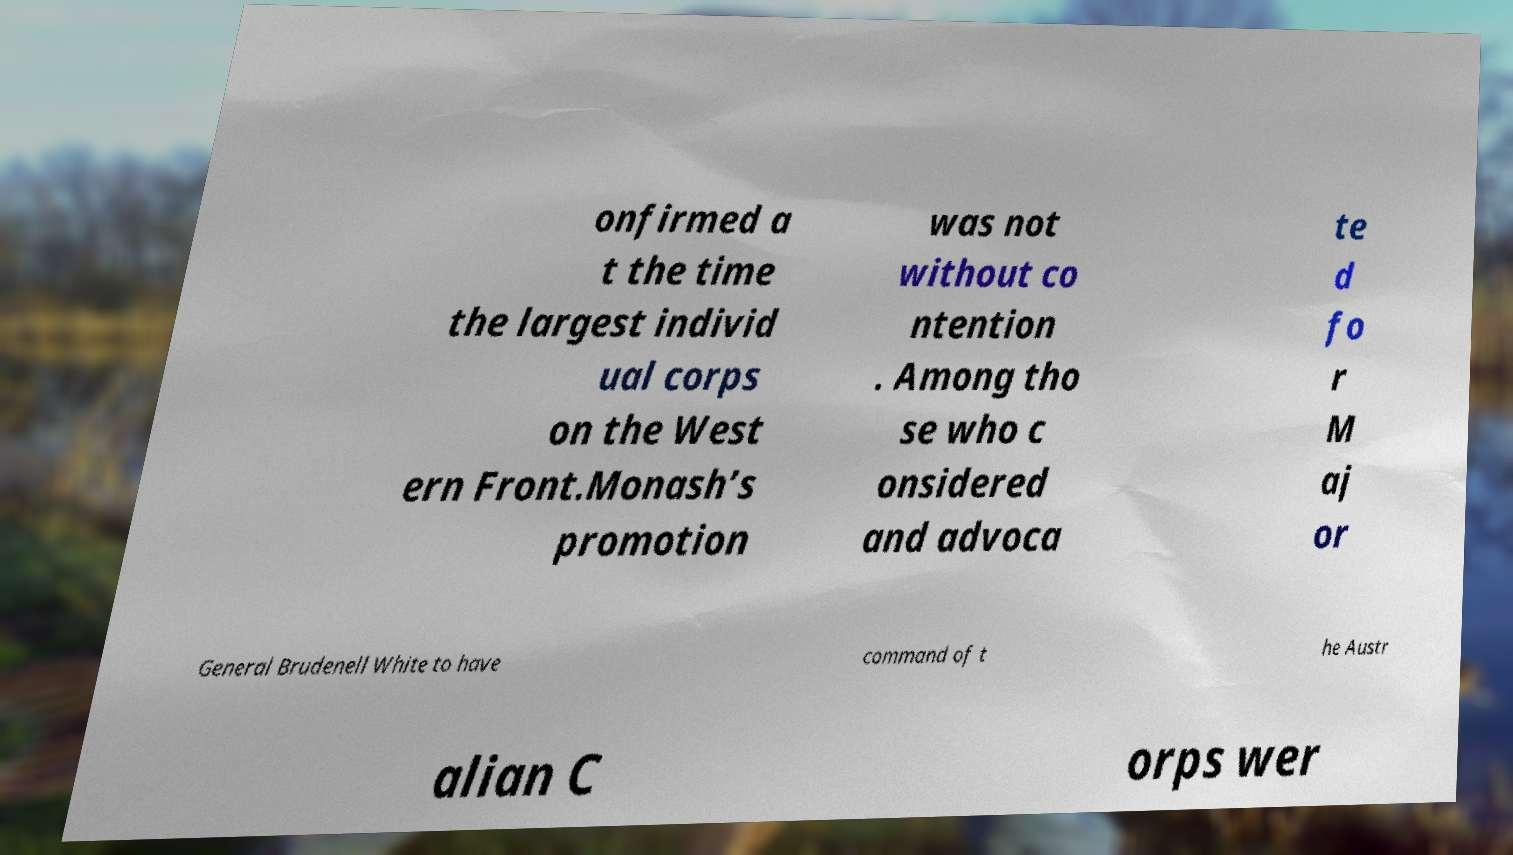Could you extract and type out the text from this image? onfirmed a t the time the largest individ ual corps on the West ern Front.Monash’s promotion was not without co ntention . Among tho se who c onsidered and advoca te d fo r M aj or General Brudenell White to have command of t he Austr alian C orps wer 